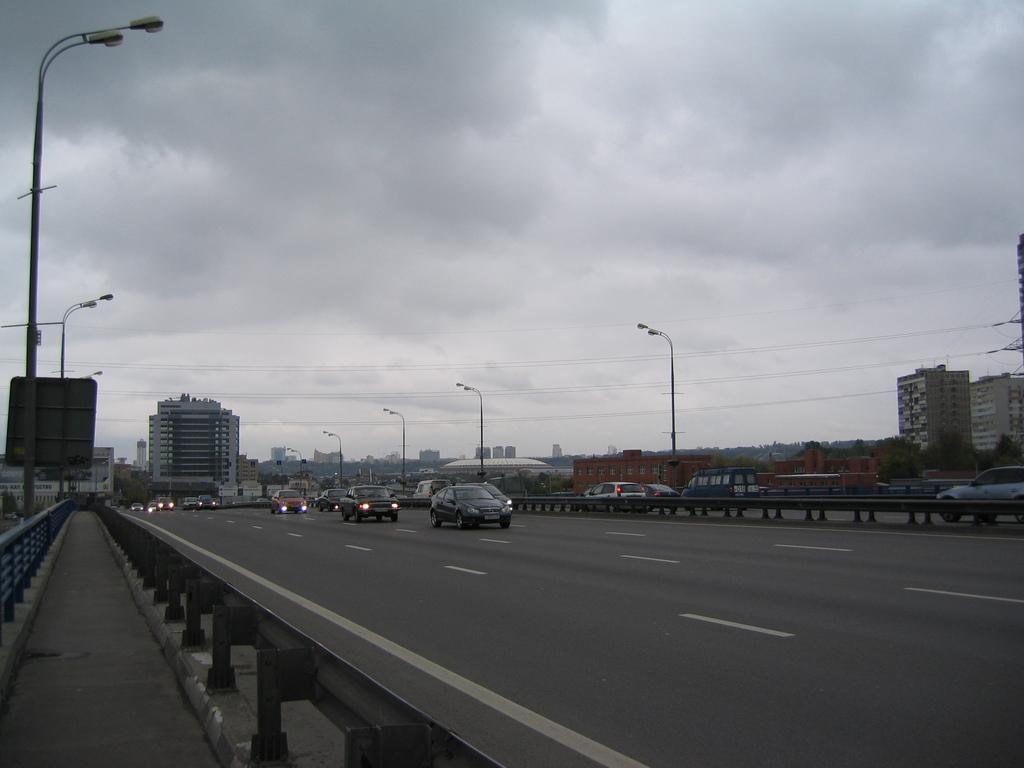In one or two sentences, can you explain what this image depicts? The picture is taken outside a city. In the foreground of the picture there are road, railing and footpath. In the center of the picture there are cars, buildings, street light and trees. Sky is cloudy. 